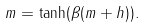<formula> <loc_0><loc_0><loc_500><loc_500>m = \tanh ( \beta ( m + h ) ) .</formula> 